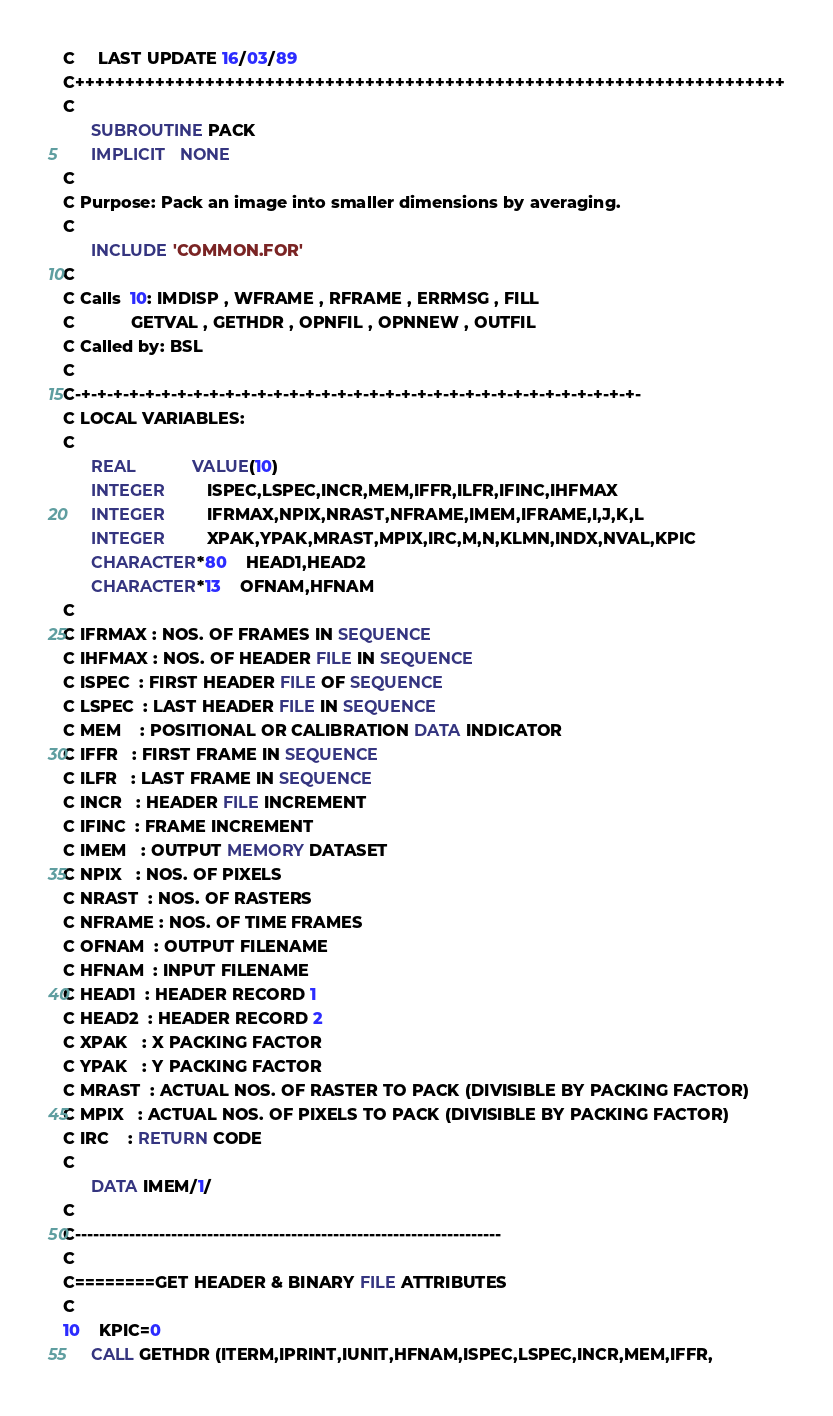Convert code to text. <code><loc_0><loc_0><loc_500><loc_500><_FORTRAN_>C     LAST UPDATE 16/03/89
C+++++++++++++++++++++++++++++++++++++++++++++++++++++++++++++++++++++++
C
      SUBROUTINE PACK
      IMPLICIT   NONE
C
C Purpose: Pack an image into smaller dimensions by averaging.
C
      INCLUDE 'COMMON.FOR'
C
C Calls  10: IMDISP , WFRAME , RFRAME , ERRMSG , FILL
C            GETVAL , GETHDR , OPNFIL , OPNNEW , OUTFIL
C Called by: BSL
C
C-+-+-+-+-+-+-+-+-+-+-+-+-+-+-+-+-+-+-+-+-+-+-+-+-+-+-+-+-+-+-+-+-+-+-+-
C LOCAL VARIABLES:
C
      REAL            VALUE(10)
      INTEGER         ISPEC,LSPEC,INCR,MEM,IFFR,ILFR,IFINC,IHFMAX
      INTEGER         IFRMAX,NPIX,NRAST,NFRAME,IMEM,IFRAME,I,J,K,L
      INTEGER         XPAK,YPAK,MRAST,MPIX,IRC,M,N,KLMN,INDX,NVAL,KPIC
      CHARACTER*80    HEAD1,HEAD2
      CHARACTER*13    OFNAM,HFNAM
C
C IFRMAX : NOS. OF FRAMES IN SEQUENCE
C IHFMAX : NOS. OF HEADER FILE IN SEQUENCE
C ISPEC  : FIRST HEADER FILE OF SEQUENCE
C LSPEC  : LAST HEADER FILE IN SEQUENCE
C MEM    : POSITIONAL OR CALIBRATION DATA INDICATOR
C IFFR   : FIRST FRAME IN SEQUENCE
C ILFR   : LAST FRAME IN SEQUENCE
C INCR   : HEADER FILE INCREMENT
C IFINC  : FRAME INCREMENT
C IMEM   : OUTPUT MEMORY DATASET
C NPIX   : NOS. OF PIXELS
C NRAST  : NOS. OF RASTERS
C NFRAME : NOS. OF TIME FRAMES
C OFNAM  : OUTPUT FILENAME
C HFNAM  : INPUT FILENAME
C HEAD1  : HEADER RECORD 1
C HEAD2  : HEADER RECORD 2
C XPAK   : X PACKING FACTOR
C YPAK   : Y PACKING FACTOR
C MRAST  : ACTUAL NOS. OF RASTER TO PACK (DIVISIBLE BY PACKING FACTOR)
C MPIX   : ACTUAL NOS. OF PIXELS TO PACK (DIVISIBLE BY PACKING FACTOR)
C IRC    : RETURN CODE   
C
      DATA IMEM/1/
C
C-----------------------------------------------------------------------
C
C========GET HEADER & BINARY FILE ATTRIBUTES
C
10    KPIC=0
      CALL GETHDR (ITERM,IPRINT,IUNIT,HFNAM,ISPEC,LSPEC,INCR,MEM,IFFR,</code> 